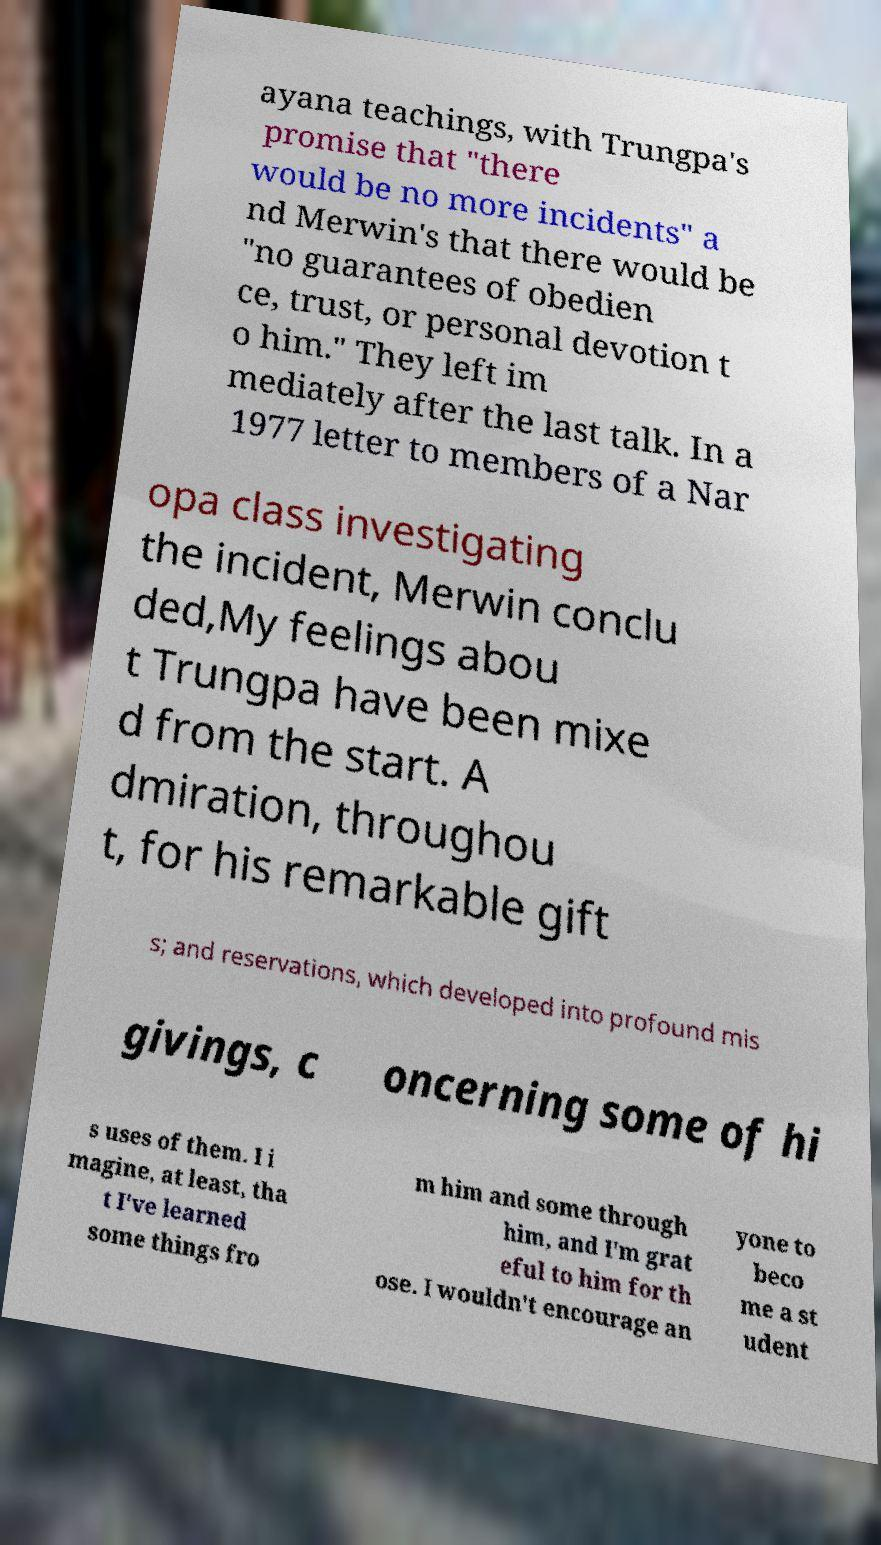What messages or text are displayed in this image? I need them in a readable, typed format. ayana teachings, with Trungpa's promise that "there would be no more incidents" a nd Merwin's that there would be "no guarantees of obedien ce, trust, or personal devotion t o him." They left im mediately after the last talk. In a 1977 letter to members of a Nar opa class investigating the incident, Merwin conclu ded,My feelings abou t Trungpa have been mixe d from the start. A dmiration, throughou t, for his remarkable gift s; and reservations, which developed into profound mis givings, c oncerning some of hi s uses of them. I i magine, at least, tha t I've learned some things fro m him and some through him, and I'm grat eful to him for th ose. I wouldn't encourage an yone to beco me a st udent 